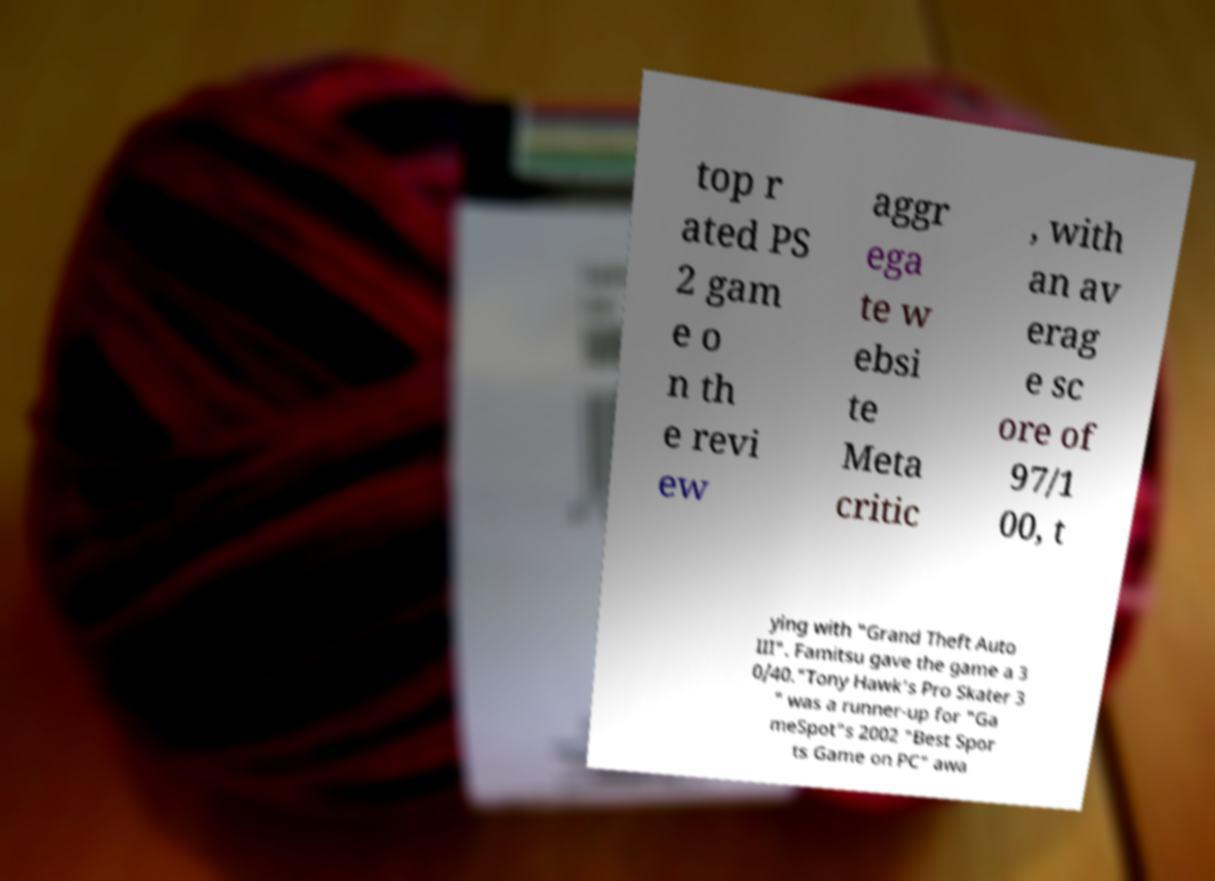What messages or text are displayed in this image? I need them in a readable, typed format. top r ated PS 2 gam e o n th e revi ew aggr ega te w ebsi te Meta critic , with an av erag e sc ore of 97/1 00, t ying with "Grand Theft Auto III". Famitsu gave the game a 3 0/40."Tony Hawk's Pro Skater 3 " was a runner-up for "Ga meSpot"s 2002 "Best Spor ts Game on PC" awa 